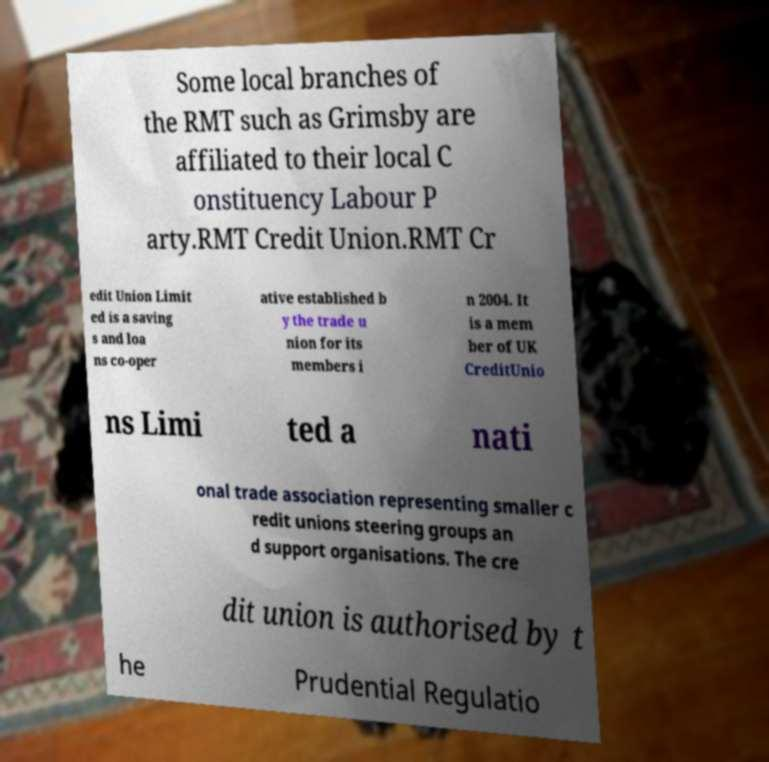I need the written content from this picture converted into text. Can you do that? Some local branches of the RMT such as Grimsby are affiliated to their local C onstituency Labour P arty.RMT Credit Union.RMT Cr edit Union Limit ed is a saving s and loa ns co-oper ative established b y the trade u nion for its members i n 2004. It is a mem ber of UK CreditUnio ns Limi ted a nati onal trade association representing smaller c redit unions steering groups an d support organisations. The cre dit union is authorised by t he Prudential Regulatio 